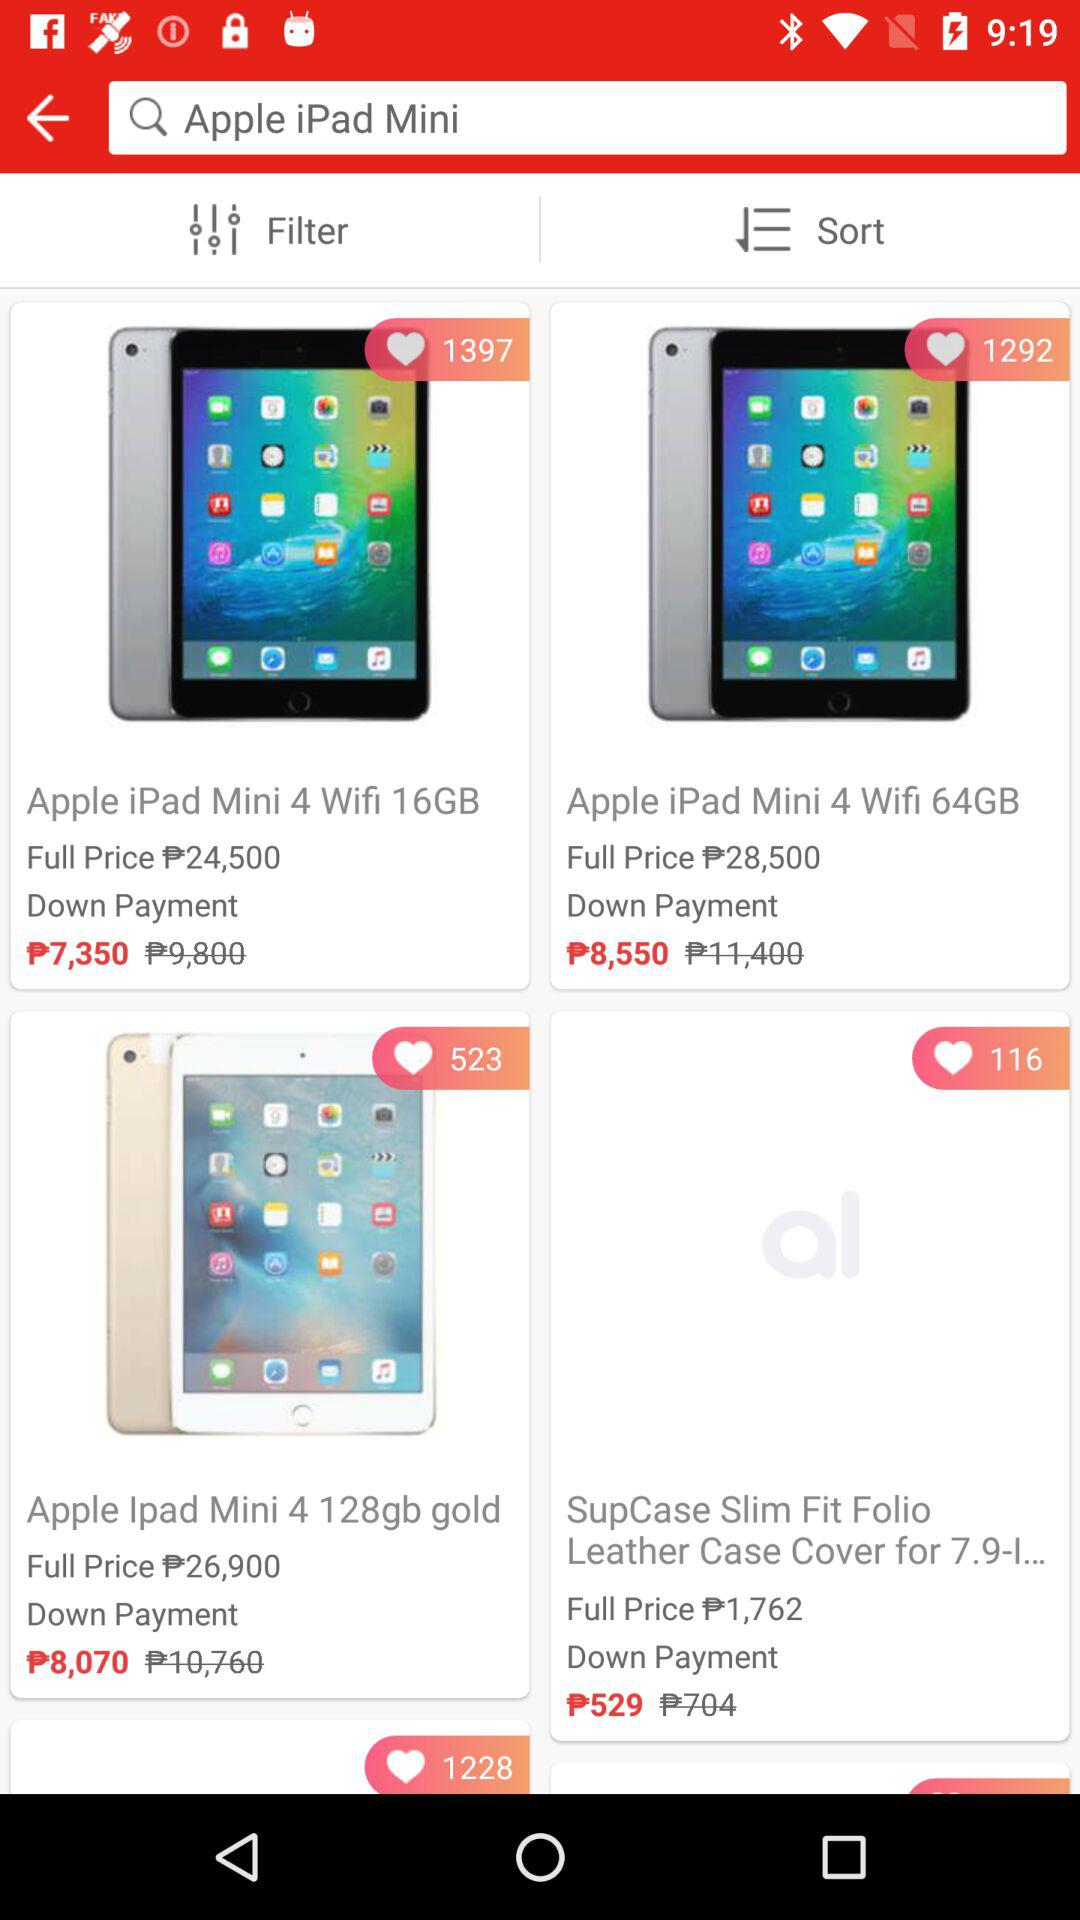How much is the new down payment for the "Apple iPad Mini 4 Wifi 64GB"? The new down payment is ₱8,550. 